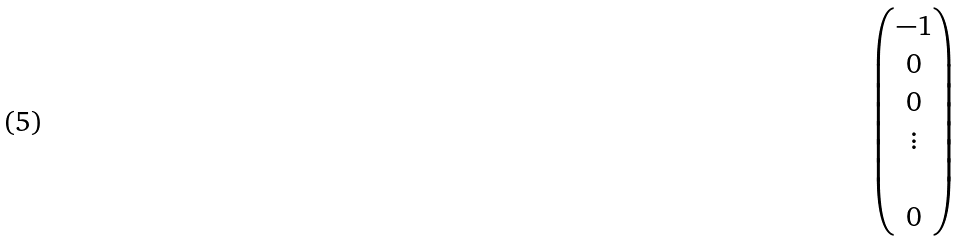Convert formula to latex. <formula><loc_0><loc_0><loc_500><loc_500>\begin{pmatrix} - 1 \\ 0 \\ 0 \\ \vdots \\ \\ 0 \end{pmatrix}</formula> 